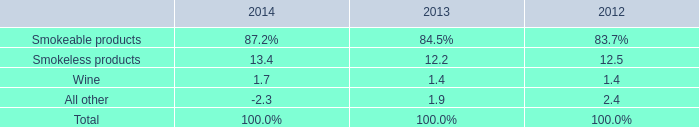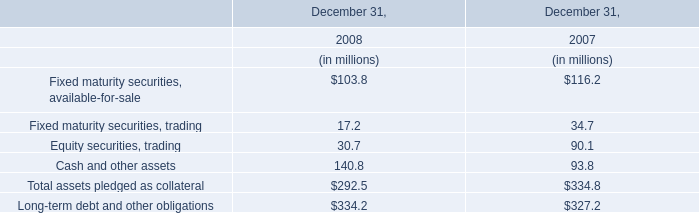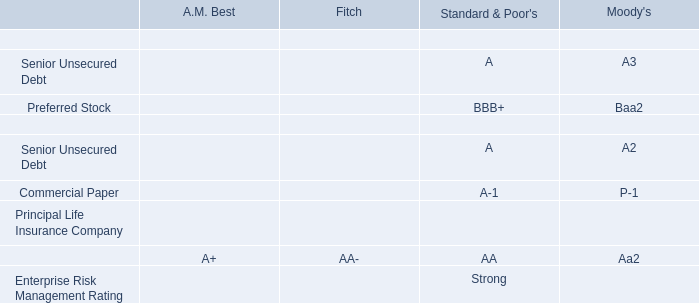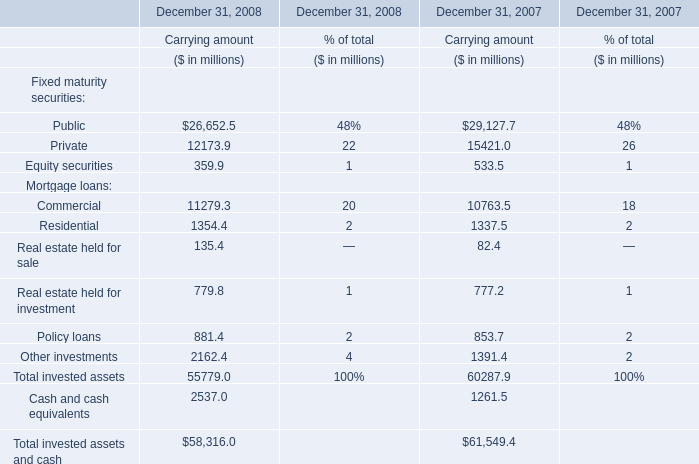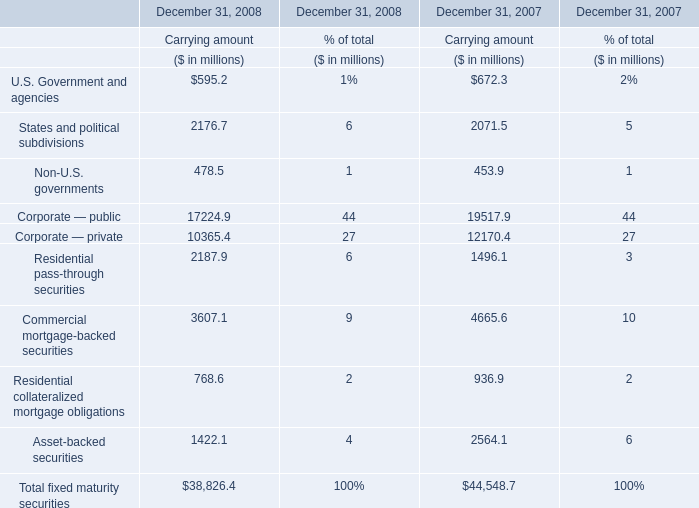Which year is Residential pass-through securities for Carrying amount the highest? 
Answer: 2008. 